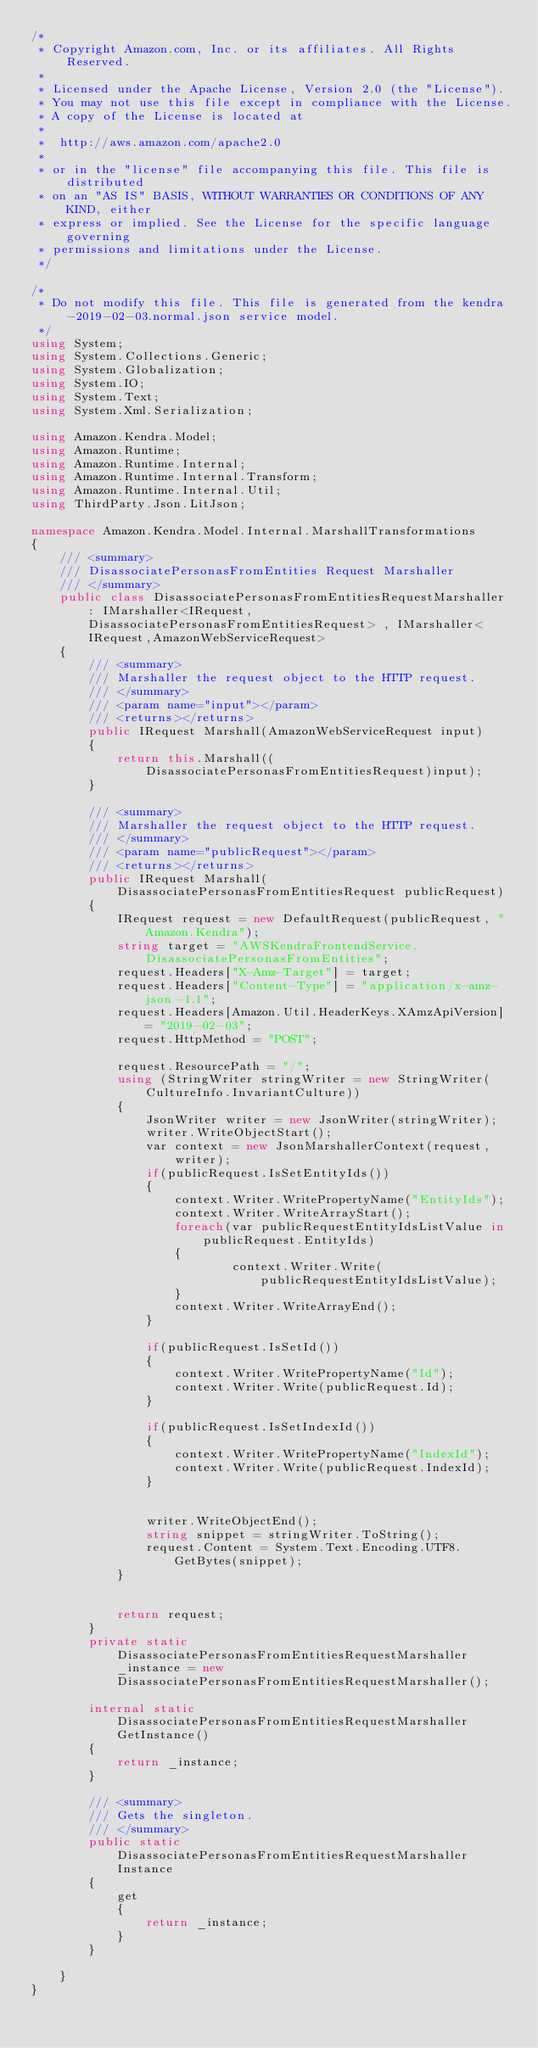Convert code to text. <code><loc_0><loc_0><loc_500><loc_500><_C#_>/*
 * Copyright Amazon.com, Inc. or its affiliates. All Rights Reserved.
 * 
 * Licensed under the Apache License, Version 2.0 (the "License").
 * You may not use this file except in compliance with the License.
 * A copy of the License is located at
 * 
 *  http://aws.amazon.com/apache2.0
 * 
 * or in the "license" file accompanying this file. This file is distributed
 * on an "AS IS" BASIS, WITHOUT WARRANTIES OR CONDITIONS OF ANY KIND, either
 * express or implied. See the License for the specific language governing
 * permissions and limitations under the License.
 */

/*
 * Do not modify this file. This file is generated from the kendra-2019-02-03.normal.json service model.
 */
using System;
using System.Collections.Generic;
using System.Globalization;
using System.IO;
using System.Text;
using System.Xml.Serialization;

using Amazon.Kendra.Model;
using Amazon.Runtime;
using Amazon.Runtime.Internal;
using Amazon.Runtime.Internal.Transform;
using Amazon.Runtime.Internal.Util;
using ThirdParty.Json.LitJson;

namespace Amazon.Kendra.Model.Internal.MarshallTransformations
{
    /// <summary>
    /// DisassociatePersonasFromEntities Request Marshaller
    /// </summary>       
    public class DisassociatePersonasFromEntitiesRequestMarshaller : IMarshaller<IRequest, DisassociatePersonasFromEntitiesRequest> , IMarshaller<IRequest,AmazonWebServiceRequest>
    {
        /// <summary>
        /// Marshaller the request object to the HTTP request.
        /// </summary>  
        /// <param name="input"></param>
        /// <returns></returns>
        public IRequest Marshall(AmazonWebServiceRequest input)
        {
            return this.Marshall((DisassociatePersonasFromEntitiesRequest)input);
        }

        /// <summary>
        /// Marshaller the request object to the HTTP request.
        /// </summary>  
        /// <param name="publicRequest"></param>
        /// <returns></returns>
        public IRequest Marshall(DisassociatePersonasFromEntitiesRequest publicRequest)
        {
            IRequest request = new DefaultRequest(publicRequest, "Amazon.Kendra");
            string target = "AWSKendraFrontendService.DisassociatePersonasFromEntities";
            request.Headers["X-Amz-Target"] = target;
            request.Headers["Content-Type"] = "application/x-amz-json-1.1";
            request.Headers[Amazon.Util.HeaderKeys.XAmzApiVersion] = "2019-02-03";            
            request.HttpMethod = "POST";

            request.ResourcePath = "/";
            using (StringWriter stringWriter = new StringWriter(CultureInfo.InvariantCulture))
            {
                JsonWriter writer = new JsonWriter(stringWriter);
                writer.WriteObjectStart();
                var context = new JsonMarshallerContext(request, writer);
                if(publicRequest.IsSetEntityIds())
                {
                    context.Writer.WritePropertyName("EntityIds");
                    context.Writer.WriteArrayStart();
                    foreach(var publicRequestEntityIdsListValue in publicRequest.EntityIds)
                    {
                            context.Writer.Write(publicRequestEntityIdsListValue);
                    }
                    context.Writer.WriteArrayEnd();
                }

                if(publicRequest.IsSetId())
                {
                    context.Writer.WritePropertyName("Id");
                    context.Writer.Write(publicRequest.Id);
                }

                if(publicRequest.IsSetIndexId())
                {
                    context.Writer.WritePropertyName("IndexId");
                    context.Writer.Write(publicRequest.IndexId);
                }

        
                writer.WriteObjectEnd();
                string snippet = stringWriter.ToString();
                request.Content = System.Text.Encoding.UTF8.GetBytes(snippet);
            }


            return request;
        }
        private static DisassociatePersonasFromEntitiesRequestMarshaller _instance = new DisassociatePersonasFromEntitiesRequestMarshaller();        

        internal static DisassociatePersonasFromEntitiesRequestMarshaller GetInstance()
        {
            return _instance;
        }

        /// <summary>
        /// Gets the singleton.
        /// </summary>  
        public static DisassociatePersonasFromEntitiesRequestMarshaller Instance
        {
            get
            {
                return _instance;
            }
        }

    }
}</code> 